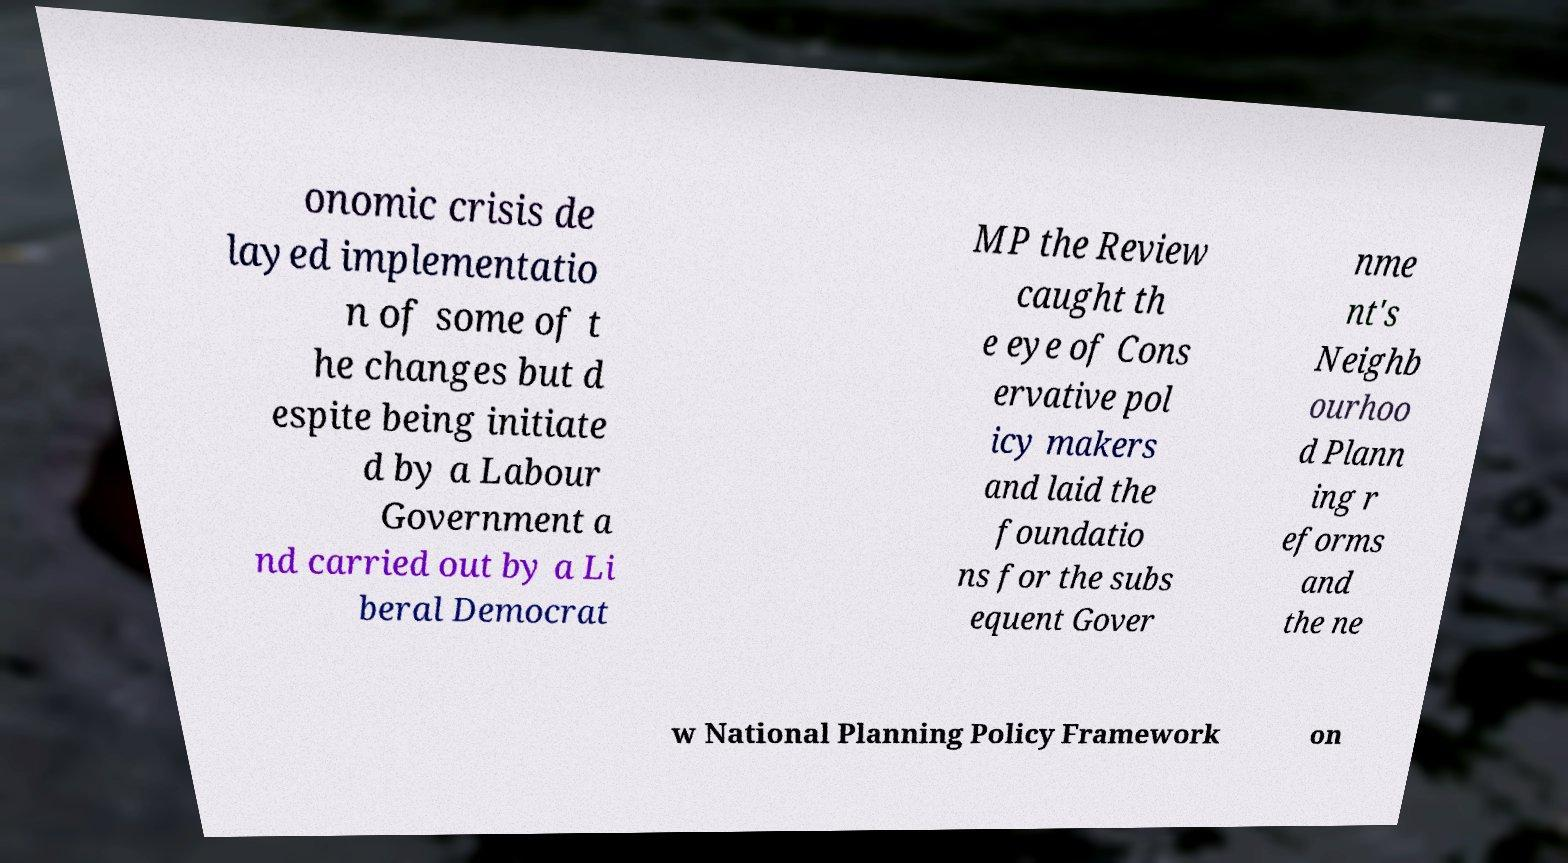There's text embedded in this image that I need extracted. Can you transcribe it verbatim? onomic crisis de layed implementatio n of some of t he changes but d espite being initiate d by a Labour Government a nd carried out by a Li beral Democrat MP the Review caught th e eye of Cons ervative pol icy makers and laid the foundatio ns for the subs equent Gover nme nt's Neighb ourhoo d Plann ing r eforms and the ne w National Planning Policy Framework on 